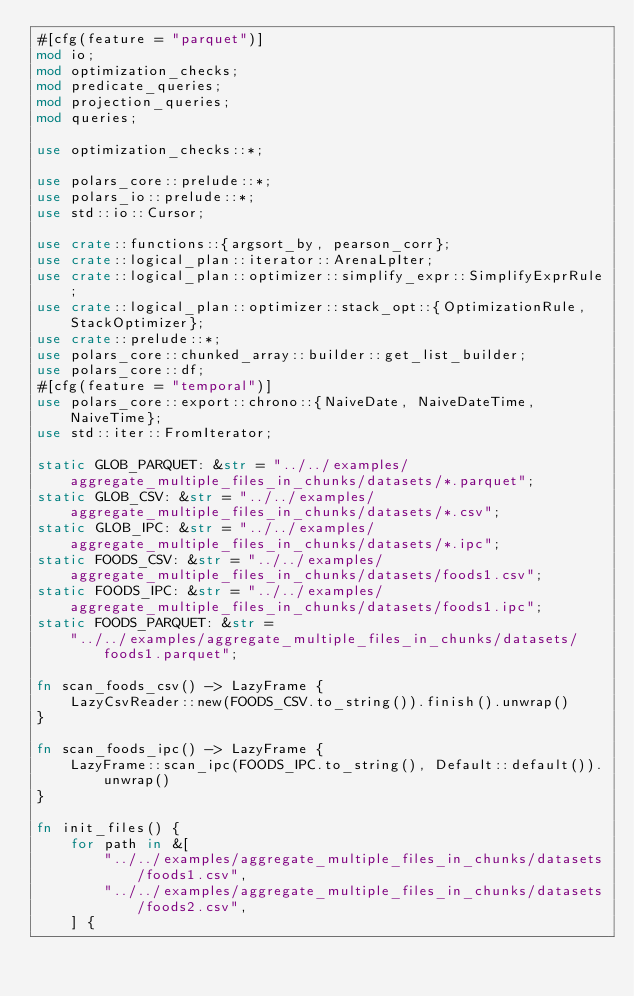<code> <loc_0><loc_0><loc_500><loc_500><_Rust_>#[cfg(feature = "parquet")]
mod io;
mod optimization_checks;
mod predicate_queries;
mod projection_queries;
mod queries;

use optimization_checks::*;

use polars_core::prelude::*;
use polars_io::prelude::*;
use std::io::Cursor;

use crate::functions::{argsort_by, pearson_corr};
use crate::logical_plan::iterator::ArenaLpIter;
use crate::logical_plan::optimizer::simplify_expr::SimplifyExprRule;
use crate::logical_plan::optimizer::stack_opt::{OptimizationRule, StackOptimizer};
use crate::prelude::*;
use polars_core::chunked_array::builder::get_list_builder;
use polars_core::df;
#[cfg(feature = "temporal")]
use polars_core::export::chrono::{NaiveDate, NaiveDateTime, NaiveTime};
use std::iter::FromIterator;

static GLOB_PARQUET: &str = "../../examples/aggregate_multiple_files_in_chunks/datasets/*.parquet";
static GLOB_CSV: &str = "../../examples/aggregate_multiple_files_in_chunks/datasets/*.csv";
static GLOB_IPC: &str = "../../examples/aggregate_multiple_files_in_chunks/datasets/*.ipc";
static FOODS_CSV: &str = "../../examples/aggregate_multiple_files_in_chunks/datasets/foods1.csv";
static FOODS_IPC: &str = "../../examples/aggregate_multiple_files_in_chunks/datasets/foods1.ipc";
static FOODS_PARQUET: &str =
    "../../examples/aggregate_multiple_files_in_chunks/datasets/foods1.parquet";

fn scan_foods_csv() -> LazyFrame {
    LazyCsvReader::new(FOODS_CSV.to_string()).finish().unwrap()
}

fn scan_foods_ipc() -> LazyFrame {
    LazyFrame::scan_ipc(FOODS_IPC.to_string(), Default::default()).unwrap()
}

fn init_files() {
    for path in &[
        "../../examples/aggregate_multiple_files_in_chunks/datasets/foods1.csv",
        "../../examples/aggregate_multiple_files_in_chunks/datasets/foods2.csv",
    ] {</code> 